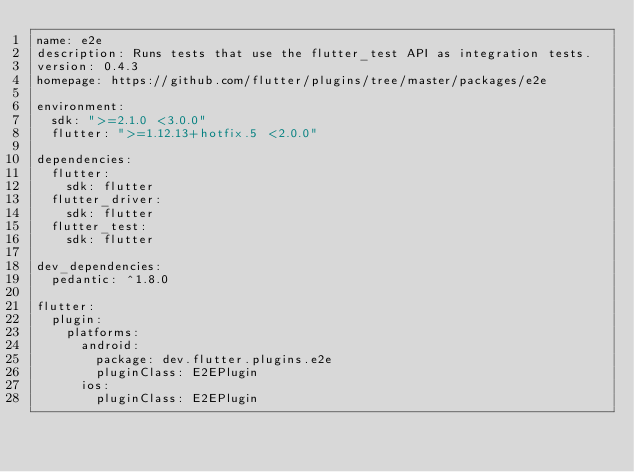Convert code to text. <code><loc_0><loc_0><loc_500><loc_500><_YAML_>name: e2e
description: Runs tests that use the flutter_test API as integration tests.
version: 0.4.3
homepage: https://github.com/flutter/plugins/tree/master/packages/e2e

environment:
  sdk: ">=2.1.0 <3.0.0"
  flutter: ">=1.12.13+hotfix.5 <2.0.0"

dependencies:
  flutter:
    sdk: flutter
  flutter_driver:
    sdk: flutter
  flutter_test:
    sdk: flutter

dev_dependencies:
  pedantic: ^1.8.0

flutter:
  plugin:
    platforms:
      android:
        package: dev.flutter.plugins.e2e
        pluginClass: E2EPlugin
      ios:
        pluginClass: E2EPlugin
</code> 